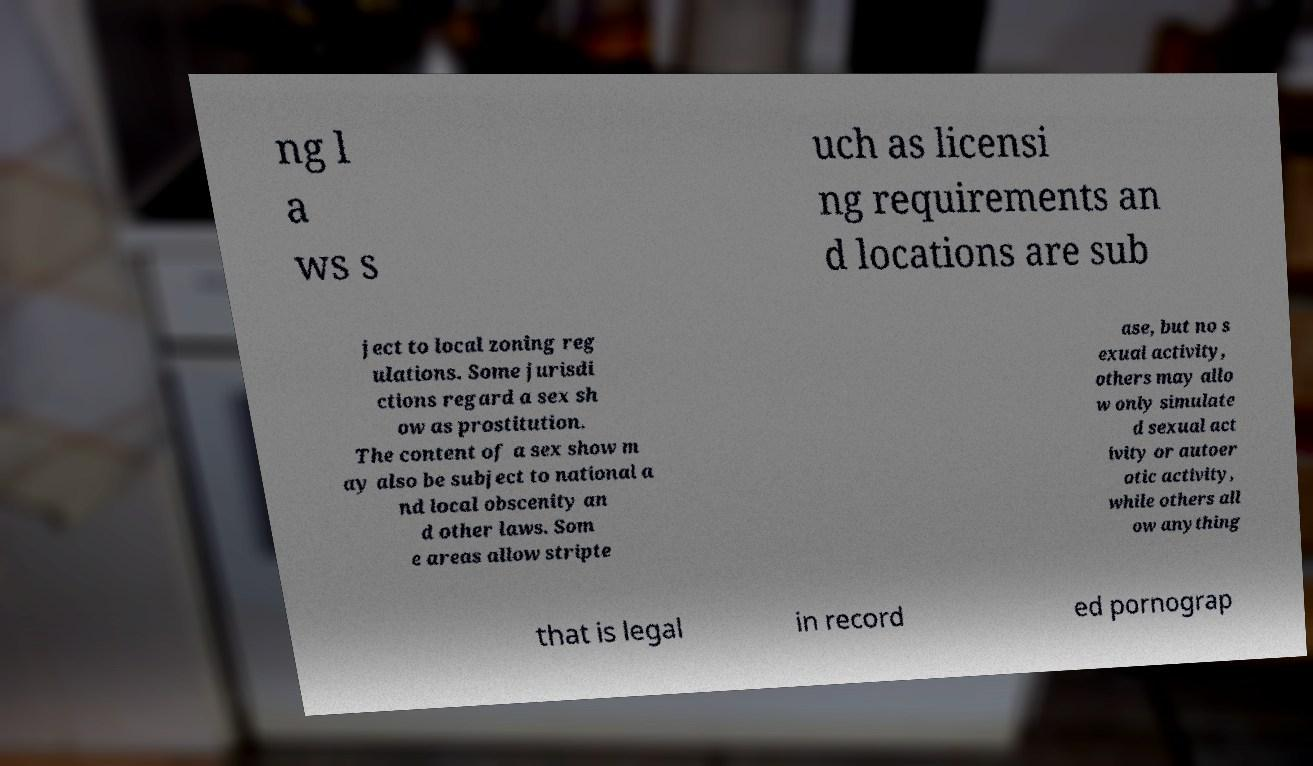Can you accurately transcribe the text from the provided image for me? ng l a ws s uch as licensi ng requirements an d locations are sub ject to local zoning reg ulations. Some jurisdi ctions regard a sex sh ow as prostitution. The content of a sex show m ay also be subject to national a nd local obscenity an d other laws. Som e areas allow stripte ase, but no s exual activity, others may allo w only simulate d sexual act ivity or autoer otic activity, while others all ow anything that is legal in record ed pornograp 